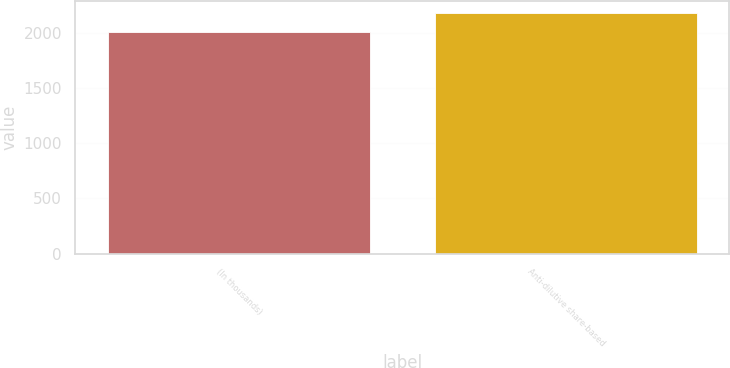Convert chart to OTSL. <chart><loc_0><loc_0><loc_500><loc_500><bar_chart><fcel>(In thousands)<fcel>Anti-dilutive share-based<nl><fcel>2008<fcel>2179<nl></chart> 